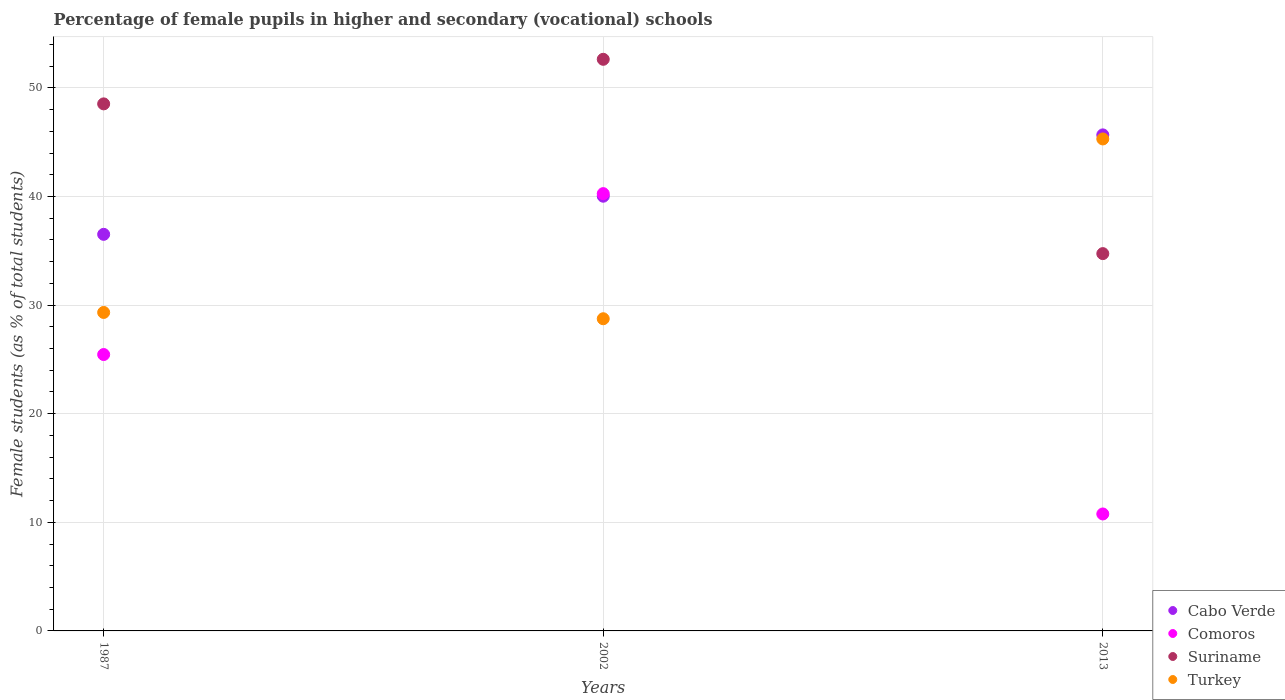Is the number of dotlines equal to the number of legend labels?
Provide a succinct answer. Yes. What is the percentage of female pupils in higher and secondary schools in Suriname in 2013?
Provide a succinct answer. 34.74. Across all years, what is the maximum percentage of female pupils in higher and secondary schools in Comoros?
Make the answer very short. 40.27. Across all years, what is the minimum percentage of female pupils in higher and secondary schools in Comoros?
Offer a very short reply. 10.77. In which year was the percentage of female pupils in higher and secondary schools in Turkey maximum?
Make the answer very short. 2013. What is the total percentage of female pupils in higher and secondary schools in Comoros in the graph?
Provide a succinct answer. 76.48. What is the difference between the percentage of female pupils in higher and secondary schools in Comoros in 1987 and that in 2013?
Offer a terse response. 14.68. What is the difference between the percentage of female pupils in higher and secondary schools in Turkey in 2013 and the percentage of female pupils in higher and secondary schools in Cabo Verde in 1987?
Offer a very short reply. 8.78. What is the average percentage of female pupils in higher and secondary schools in Comoros per year?
Provide a short and direct response. 25.49. In the year 2002, what is the difference between the percentage of female pupils in higher and secondary schools in Comoros and percentage of female pupils in higher and secondary schools in Turkey?
Your response must be concise. 11.52. In how many years, is the percentage of female pupils in higher and secondary schools in Suriname greater than 24 %?
Your answer should be compact. 3. What is the ratio of the percentage of female pupils in higher and secondary schools in Suriname in 1987 to that in 2013?
Offer a terse response. 1.4. What is the difference between the highest and the second highest percentage of female pupils in higher and secondary schools in Cabo Verde?
Offer a terse response. 5.65. What is the difference between the highest and the lowest percentage of female pupils in higher and secondary schools in Comoros?
Provide a succinct answer. 29.5. Is the sum of the percentage of female pupils in higher and secondary schools in Suriname in 1987 and 2013 greater than the maximum percentage of female pupils in higher and secondary schools in Cabo Verde across all years?
Your answer should be very brief. Yes. Is it the case that in every year, the sum of the percentage of female pupils in higher and secondary schools in Turkey and percentage of female pupils in higher and secondary schools in Comoros  is greater than the percentage of female pupils in higher and secondary schools in Suriname?
Your answer should be very brief. Yes. Does the percentage of female pupils in higher and secondary schools in Cabo Verde monotonically increase over the years?
Your response must be concise. Yes. Is the percentage of female pupils in higher and secondary schools in Comoros strictly greater than the percentage of female pupils in higher and secondary schools in Cabo Verde over the years?
Keep it short and to the point. No. How many dotlines are there?
Offer a very short reply. 4. What is the difference between two consecutive major ticks on the Y-axis?
Your answer should be very brief. 10. Are the values on the major ticks of Y-axis written in scientific E-notation?
Your answer should be compact. No. Does the graph contain any zero values?
Make the answer very short. No. How many legend labels are there?
Keep it short and to the point. 4. How are the legend labels stacked?
Ensure brevity in your answer.  Vertical. What is the title of the graph?
Give a very brief answer. Percentage of female pupils in higher and secondary (vocational) schools. What is the label or title of the X-axis?
Make the answer very short. Years. What is the label or title of the Y-axis?
Provide a short and direct response. Female students (as % of total students). What is the Female students (as % of total students) of Cabo Verde in 1987?
Your answer should be very brief. 36.52. What is the Female students (as % of total students) in Comoros in 1987?
Keep it short and to the point. 25.45. What is the Female students (as % of total students) in Suriname in 1987?
Your response must be concise. 48.53. What is the Female students (as % of total students) of Turkey in 1987?
Your answer should be very brief. 29.33. What is the Female students (as % of total students) in Cabo Verde in 2002?
Ensure brevity in your answer.  40.03. What is the Female students (as % of total students) in Comoros in 2002?
Keep it short and to the point. 40.27. What is the Female students (as % of total students) of Suriname in 2002?
Your answer should be very brief. 52.63. What is the Female students (as % of total students) of Turkey in 2002?
Provide a succinct answer. 28.75. What is the Female students (as % of total students) in Cabo Verde in 2013?
Ensure brevity in your answer.  45.67. What is the Female students (as % of total students) in Comoros in 2013?
Your response must be concise. 10.77. What is the Female students (as % of total students) of Suriname in 2013?
Your answer should be compact. 34.74. What is the Female students (as % of total students) in Turkey in 2013?
Give a very brief answer. 45.3. Across all years, what is the maximum Female students (as % of total students) in Cabo Verde?
Make the answer very short. 45.67. Across all years, what is the maximum Female students (as % of total students) in Comoros?
Keep it short and to the point. 40.27. Across all years, what is the maximum Female students (as % of total students) in Suriname?
Make the answer very short. 52.63. Across all years, what is the maximum Female students (as % of total students) in Turkey?
Give a very brief answer. 45.3. Across all years, what is the minimum Female students (as % of total students) of Cabo Verde?
Provide a short and direct response. 36.52. Across all years, what is the minimum Female students (as % of total students) of Comoros?
Provide a succinct answer. 10.77. Across all years, what is the minimum Female students (as % of total students) in Suriname?
Offer a very short reply. 34.74. Across all years, what is the minimum Female students (as % of total students) in Turkey?
Keep it short and to the point. 28.75. What is the total Female students (as % of total students) in Cabo Verde in the graph?
Your response must be concise. 122.22. What is the total Female students (as % of total students) in Comoros in the graph?
Provide a succinct answer. 76.48. What is the total Female students (as % of total students) of Suriname in the graph?
Keep it short and to the point. 135.91. What is the total Female students (as % of total students) of Turkey in the graph?
Ensure brevity in your answer.  103.37. What is the difference between the Female students (as % of total students) of Cabo Verde in 1987 and that in 2002?
Give a very brief answer. -3.51. What is the difference between the Female students (as % of total students) of Comoros in 1987 and that in 2002?
Provide a short and direct response. -14.82. What is the difference between the Female students (as % of total students) in Suriname in 1987 and that in 2002?
Make the answer very short. -4.1. What is the difference between the Female students (as % of total students) of Turkey in 1987 and that in 2002?
Give a very brief answer. 0.58. What is the difference between the Female students (as % of total students) of Cabo Verde in 1987 and that in 2013?
Make the answer very short. -9.16. What is the difference between the Female students (as % of total students) of Comoros in 1987 and that in 2013?
Keep it short and to the point. 14.68. What is the difference between the Female students (as % of total students) in Suriname in 1987 and that in 2013?
Ensure brevity in your answer.  13.79. What is the difference between the Female students (as % of total students) of Turkey in 1987 and that in 2013?
Give a very brief answer. -15.98. What is the difference between the Female students (as % of total students) in Cabo Verde in 2002 and that in 2013?
Provide a short and direct response. -5.65. What is the difference between the Female students (as % of total students) in Comoros in 2002 and that in 2013?
Offer a very short reply. 29.5. What is the difference between the Female students (as % of total students) of Suriname in 2002 and that in 2013?
Your response must be concise. 17.89. What is the difference between the Female students (as % of total students) of Turkey in 2002 and that in 2013?
Provide a short and direct response. -16.56. What is the difference between the Female students (as % of total students) in Cabo Verde in 1987 and the Female students (as % of total students) in Comoros in 2002?
Offer a terse response. -3.75. What is the difference between the Female students (as % of total students) of Cabo Verde in 1987 and the Female students (as % of total students) of Suriname in 2002?
Ensure brevity in your answer.  -16.12. What is the difference between the Female students (as % of total students) in Cabo Verde in 1987 and the Female students (as % of total students) in Turkey in 2002?
Your answer should be compact. 7.77. What is the difference between the Female students (as % of total students) of Comoros in 1987 and the Female students (as % of total students) of Suriname in 2002?
Provide a succinct answer. -27.19. What is the difference between the Female students (as % of total students) of Comoros in 1987 and the Female students (as % of total students) of Turkey in 2002?
Offer a very short reply. -3.3. What is the difference between the Female students (as % of total students) of Suriname in 1987 and the Female students (as % of total students) of Turkey in 2002?
Your response must be concise. 19.79. What is the difference between the Female students (as % of total students) of Cabo Verde in 1987 and the Female students (as % of total students) of Comoros in 2013?
Give a very brief answer. 25.75. What is the difference between the Female students (as % of total students) in Cabo Verde in 1987 and the Female students (as % of total students) in Suriname in 2013?
Provide a succinct answer. 1.78. What is the difference between the Female students (as % of total students) in Cabo Verde in 1987 and the Female students (as % of total students) in Turkey in 2013?
Provide a succinct answer. -8.78. What is the difference between the Female students (as % of total students) of Comoros in 1987 and the Female students (as % of total students) of Suriname in 2013?
Your answer should be very brief. -9.29. What is the difference between the Female students (as % of total students) of Comoros in 1987 and the Female students (as % of total students) of Turkey in 2013?
Ensure brevity in your answer.  -19.85. What is the difference between the Female students (as % of total students) of Suriname in 1987 and the Female students (as % of total students) of Turkey in 2013?
Keep it short and to the point. 3.23. What is the difference between the Female students (as % of total students) in Cabo Verde in 2002 and the Female students (as % of total students) in Comoros in 2013?
Give a very brief answer. 29.26. What is the difference between the Female students (as % of total students) in Cabo Verde in 2002 and the Female students (as % of total students) in Suriname in 2013?
Provide a short and direct response. 5.29. What is the difference between the Female students (as % of total students) of Cabo Verde in 2002 and the Female students (as % of total students) of Turkey in 2013?
Your response must be concise. -5.27. What is the difference between the Female students (as % of total students) in Comoros in 2002 and the Female students (as % of total students) in Suriname in 2013?
Make the answer very short. 5.52. What is the difference between the Female students (as % of total students) in Comoros in 2002 and the Female students (as % of total students) in Turkey in 2013?
Provide a succinct answer. -5.04. What is the difference between the Female students (as % of total students) of Suriname in 2002 and the Female students (as % of total students) of Turkey in 2013?
Provide a short and direct response. 7.33. What is the average Female students (as % of total students) in Cabo Verde per year?
Your response must be concise. 40.74. What is the average Female students (as % of total students) in Comoros per year?
Ensure brevity in your answer.  25.49. What is the average Female students (as % of total students) of Suriname per year?
Ensure brevity in your answer.  45.3. What is the average Female students (as % of total students) in Turkey per year?
Ensure brevity in your answer.  34.46. In the year 1987, what is the difference between the Female students (as % of total students) in Cabo Verde and Female students (as % of total students) in Comoros?
Offer a very short reply. 11.07. In the year 1987, what is the difference between the Female students (as % of total students) in Cabo Verde and Female students (as % of total students) in Suriname?
Give a very brief answer. -12.01. In the year 1987, what is the difference between the Female students (as % of total students) of Cabo Verde and Female students (as % of total students) of Turkey?
Offer a very short reply. 7.19. In the year 1987, what is the difference between the Female students (as % of total students) in Comoros and Female students (as % of total students) in Suriname?
Keep it short and to the point. -23.08. In the year 1987, what is the difference between the Female students (as % of total students) of Comoros and Female students (as % of total students) of Turkey?
Provide a succinct answer. -3.88. In the year 1987, what is the difference between the Female students (as % of total students) of Suriname and Female students (as % of total students) of Turkey?
Your response must be concise. 19.21. In the year 2002, what is the difference between the Female students (as % of total students) of Cabo Verde and Female students (as % of total students) of Comoros?
Provide a succinct answer. -0.24. In the year 2002, what is the difference between the Female students (as % of total students) of Cabo Verde and Female students (as % of total students) of Suriname?
Make the answer very short. -12.61. In the year 2002, what is the difference between the Female students (as % of total students) of Cabo Verde and Female students (as % of total students) of Turkey?
Offer a terse response. 11.28. In the year 2002, what is the difference between the Female students (as % of total students) of Comoros and Female students (as % of total students) of Suriname?
Your answer should be compact. -12.37. In the year 2002, what is the difference between the Female students (as % of total students) of Comoros and Female students (as % of total students) of Turkey?
Provide a succinct answer. 11.52. In the year 2002, what is the difference between the Female students (as % of total students) of Suriname and Female students (as % of total students) of Turkey?
Give a very brief answer. 23.89. In the year 2013, what is the difference between the Female students (as % of total students) in Cabo Verde and Female students (as % of total students) in Comoros?
Ensure brevity in your answer.  34.91. In the year 2013, what is the difference between the Female students (as % of total students) of Cabo Verde and Female students (as % of total students) of Suriname?
Ensure brevity in your answer.  10.93. In the year 2013, what is the difference between the Female students (as % of total students) in Cabo Verde and Female students (as % of total students) in Turkey?
Keep it short and to the point. 0.37. In the year 2013, what is the difference between the Female students (as % of total students) in Comoros and Female students (as % of total students) in Suriname?
Your answer should be compact. -23.97. In the year 2013, what is the difference between the Female students (as % of total students) in Comoros and Female students (as % of total students) in Turkey?
Offer a very short reply. -34.53. In the year 2013, what is the difference between the Female students (as % of total students) in Suriname and Female students (as % of total students) in Turkey?
Your response must be concise. -10.56. What is the ratio of the Female students (as % of total students) in Cabo Verde in 1987 to that in 2002?
Ensure brevity in your answer.  0.91. What is the ratio of the Female students (as % of total students) of Comoros in 1987 to that in 2002?
Your response must be concise. 0.63. What is the ratio of the Female students (as % of total students) of Suriname in 1987 to that in 2002?
Give a very brief answer. 0.92. What is the ratio of the Female students (as % of total students) of Turkey in 1987 to that in 2002?
Provide a short and direct response. 1.02. What is the ratio of the Female students (as % of total students) in Cabo Verde in 1987 to that in 2013?
Your answer should be compact. 0.8. What is the ratio of the Female students (as % of total students) in Comoros in 1987 to that in 2013?
Provide a short and direct response. 2.36. What is the ratio of the Female students (as % of total students) of Suriname in 1987 to that in 2013?
Your answer should be very brief. 1.4. What is the ratio of the Female students (as % of total students) in Turkey in 1987 to that in 2013?
Ensure brevity in your answer.  0.65. What is the ratio of the Female students (as % of total students) of Cabo Verde in 2002 to that in 2013?
Give a very brief answer. 0.88. What is the ratio of the Female students (as % of total students) of Comoros in 2002 to that in 2013?
Provide a succinct answer. 3.74. What is the ratio of the Female students (as % of total students) of Suriname in 2002 to that in 2013?
Ensure brevity in your answer.  1.51. What is the ratio of the Female students (as % of total students) in Turkey in 2002 to that in 2013?
Give a very brief answer. 0.63. What is the difference between the highest and the second highest Female students (as % of total students) in Cabo Verde?
Provide a succinct answer. 5.65. What is the difference between the highest and the second highest Female students (as % of total students) in Comoros?
Offer a terse response. 14.82. What is the difference between the highest and the second highest Female students (as % of total students) in Suriname?
Your answer should be compact. 4.1. What is the difference between the highest and the second highest Female students (as % of total students) in Turkey?
Your response must be concise. 15.98. What is the difference between the highest and the lowest Female students (as % of total students) of Cabo Verde?
Your answer should be very brief. 9.16. What is the difference between the highest and the lowest Female students (as % of total students) in Comoros?
Ensure brevity in your answer.  29.5. What is the difference between the highest and the lowest Female students (as % of total students) of Suriname?
Your answer should be compact. 17.89. What is the difference between the highest and the lowest Female students (as % of total students) in Turkey?
Your response must be concise. 16.56. 